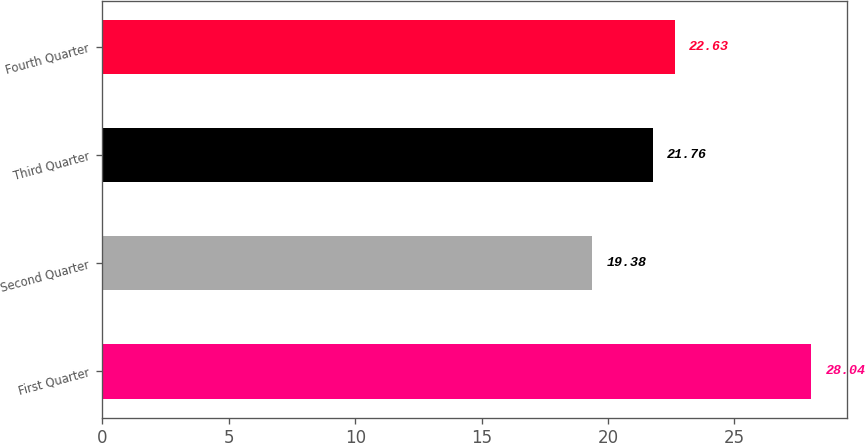Convert chart to OTSL. <chart><loc_0><loc_0><loc_500><loc_500><bar_chart><fcel>First Quarter<fcel>Second Quarter<fcel>Third Quarter<fcel>Fourth Quarter<nl><fcel>28.04<fcel>19.38<fcel>21.76<fcel>22.63<nl></chart> 